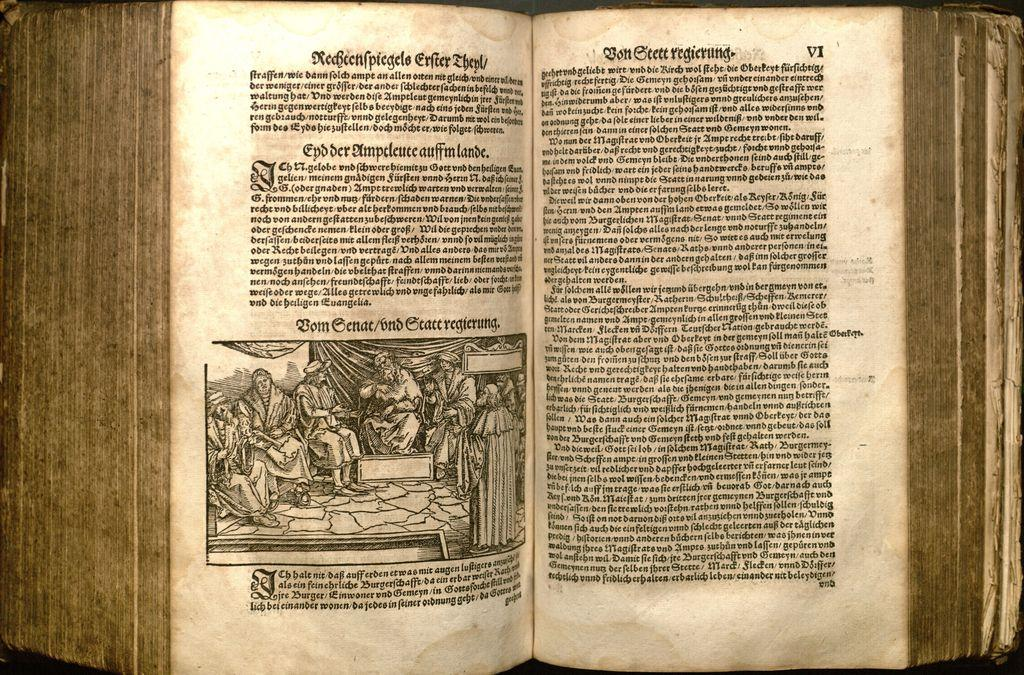<image>
Summarize the visual content of the image. A old book opened and written in foreign language saying Redeenpiegeels. 